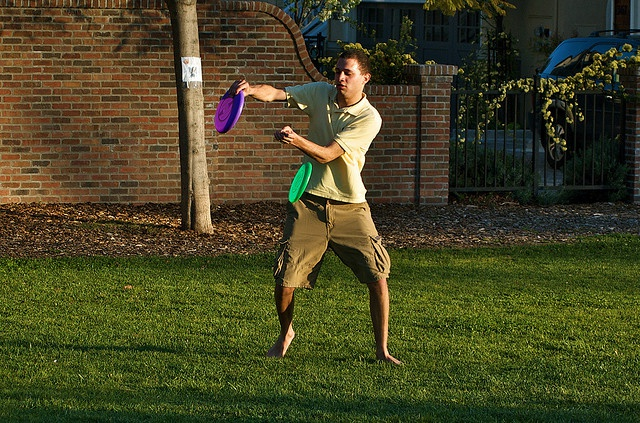Describe the objects in this image and their specific colors. I can see people in black, olive, and tan tones, car in black, navy, and blue tones, frisbee in black, navy, and purple tones, and frisbee in black, green, lightgreen, and darkgreen tones in this image. 